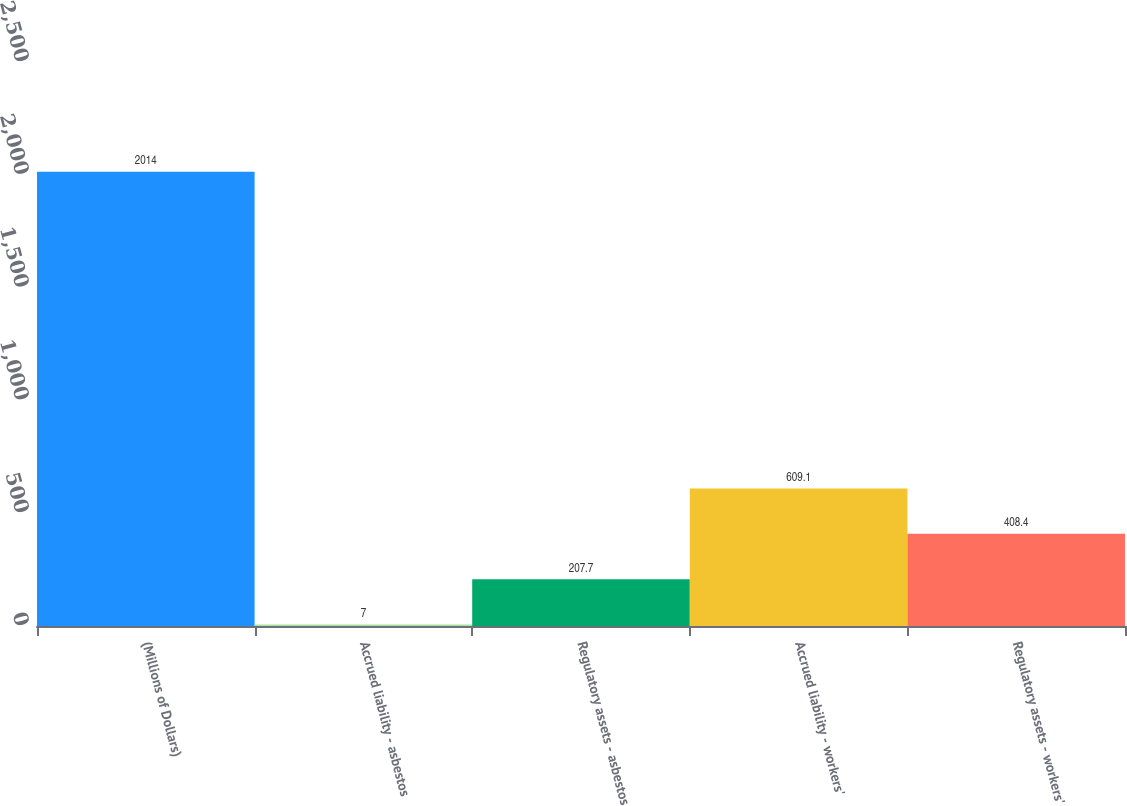<chart> <loc_0><loc_0><loc_500><loc_500><bar_chart><fcel>(Millions of Dollars)<fcel>Accrued liability - asbestos<fcel>Regulatory assets - asbestos<fcel>Accrued liability - workers'<fcel>Regulatory assets - workers'<nl><fcel>2014<fcel>7<fcel>207.7<fcel>609.1<fcel>408.4<nl></chart> 